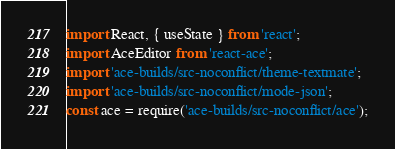Convert code to text. <code><loc_0><loc_0><loc_500><loc_500><_JavaScript_>import React, { useState } from 'react';
import AceEditor from 'react-ace';
import 'ace-builds/src-noconflict/theme-textmate';
import 'ace-builds/src-noconflict/mode-json';
const ace = require('ace-builds/src-noconflict/ace');</code> 